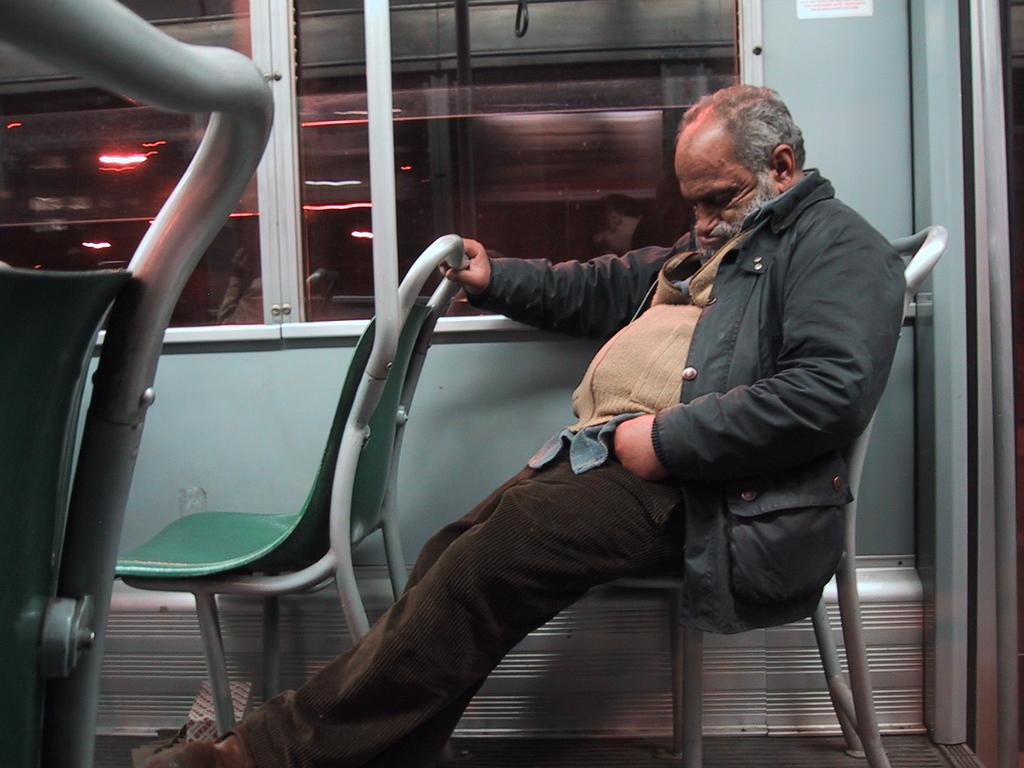Who is present in the image? There is a man in the image. What is the man doing in the image? The man is sitting on a chair in the image. Where is the man located in the image? The man is inside a vehicle in the image. What separates the man from the outside environment in the image? The man is sitting behind a glass window in the image. What type of rod can be seen in the image? There is no rod present in the image. Is the man lying on a bed in the image? No, the man is sitting on a chair in the image, not lying on a bed. 